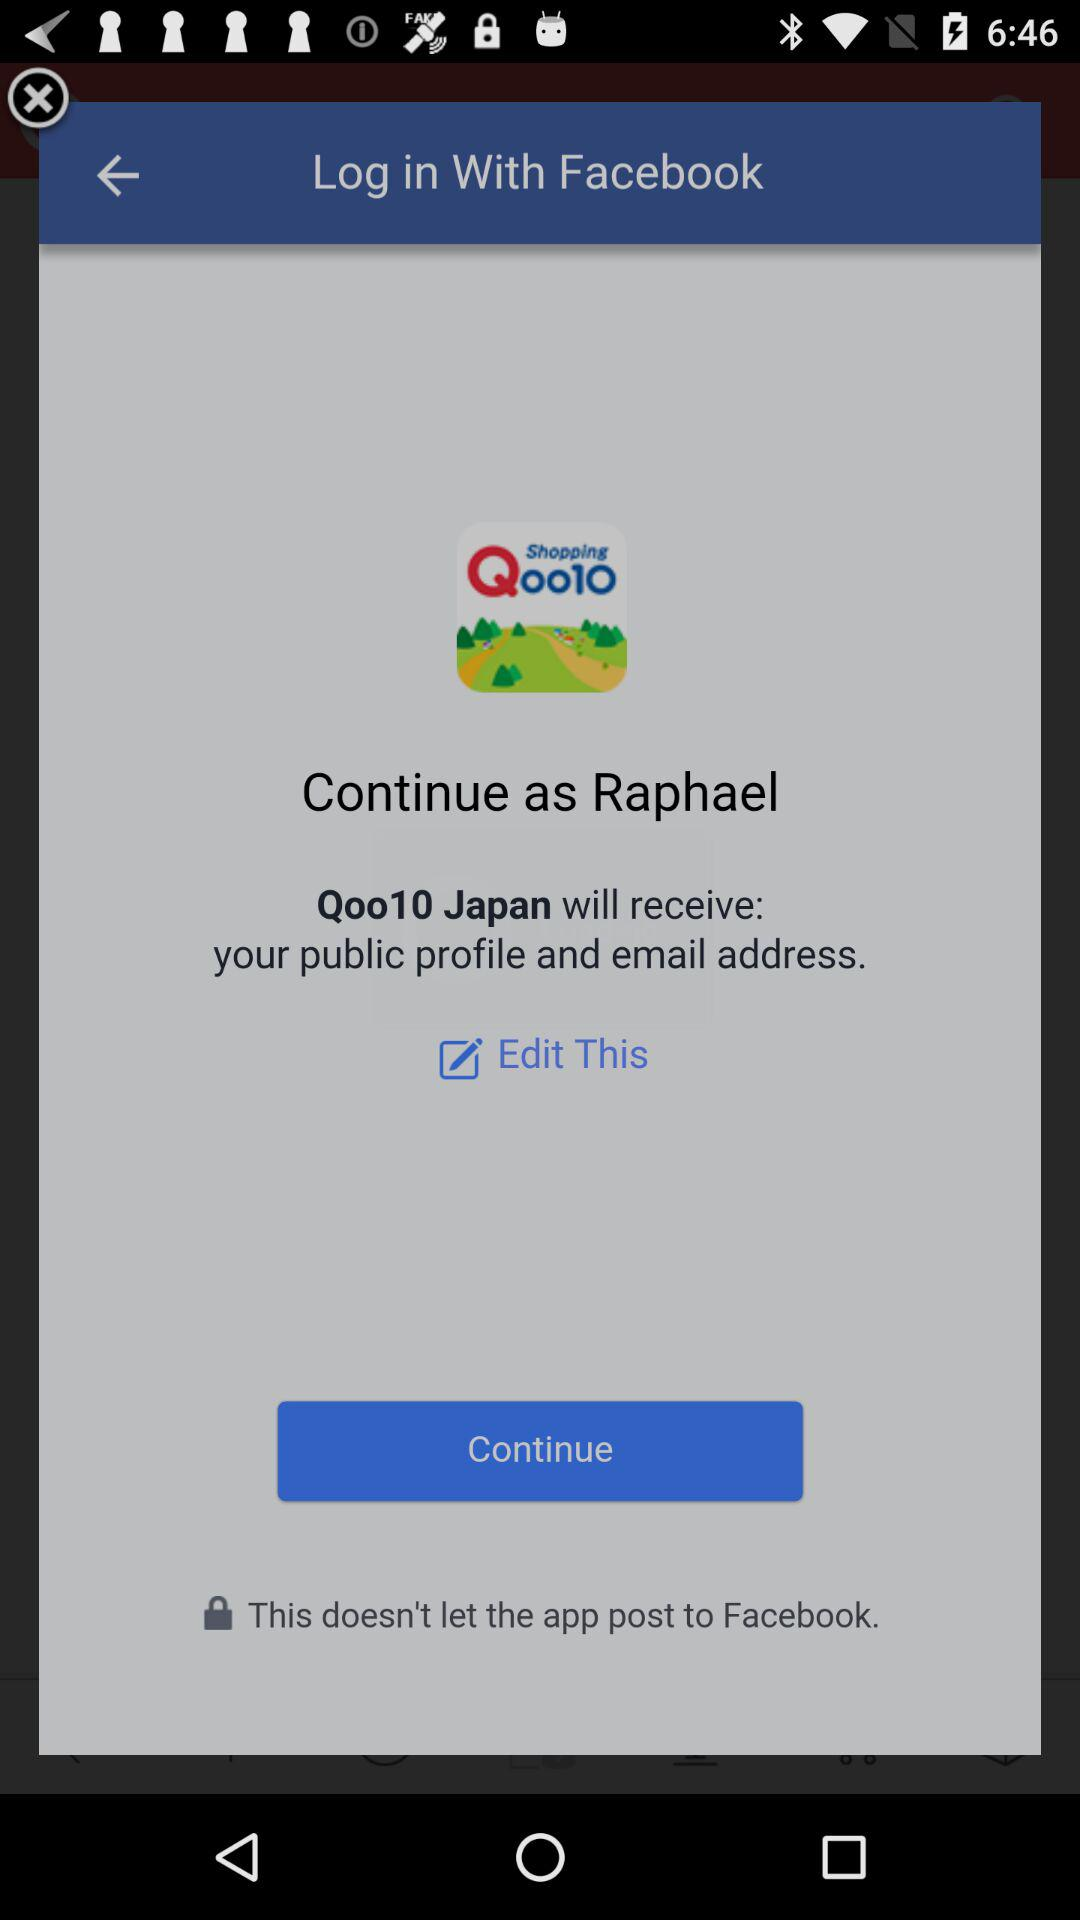What application is asking for permission? The application asking for permission is "Qoo10 Japan". 